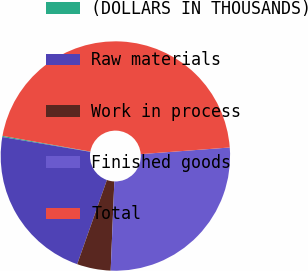<chart> <loc_0><loc_0><loc_500><loc_500><pie_chart><fcel>(DOLLARS IN THOUSANDS)<fcel>Raw materials<fcel>Work in process<fcel>Finished goods<fcel>Total<nl><fcel>0.16%<fcel>22.25%<fcel>4.75%<fcel>26.84%<fcel>46.0%<nl></chart> 